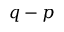Convert formula to latex. <formula><loc_0><loc_0><loc_500><loc_500>q - p</formula> 